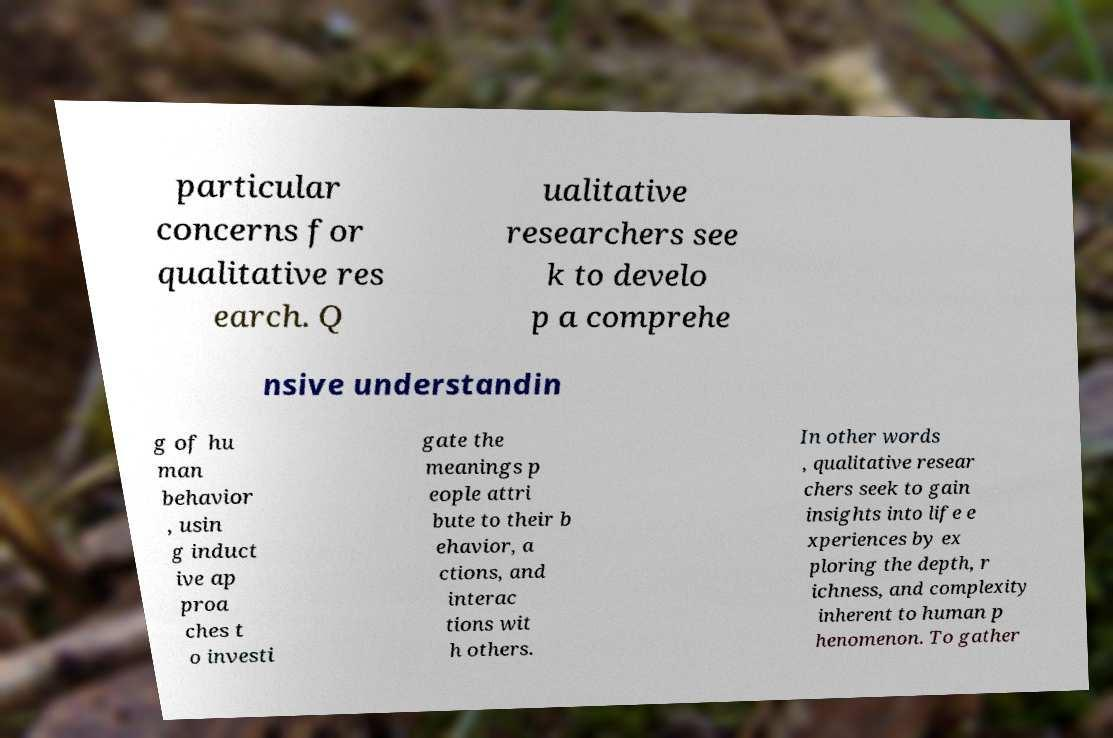Can you accurately transcribe the text from the provided image for me? particular concerns for qualitative res earch. Q ualitative researchers see k to develo p a comprehe nsive understandin g of hu man behavior , usin g induct ive ap proa ches t o investi gate the meanings p eople attri bute to their b ehavior, a ctions, and interac tions wit h others. In other words , qualitative resear chers seek to gain insights into life e xperiences by ex ploring the depth, r ichness, and complexity inherent to human p henomenon. To gather 